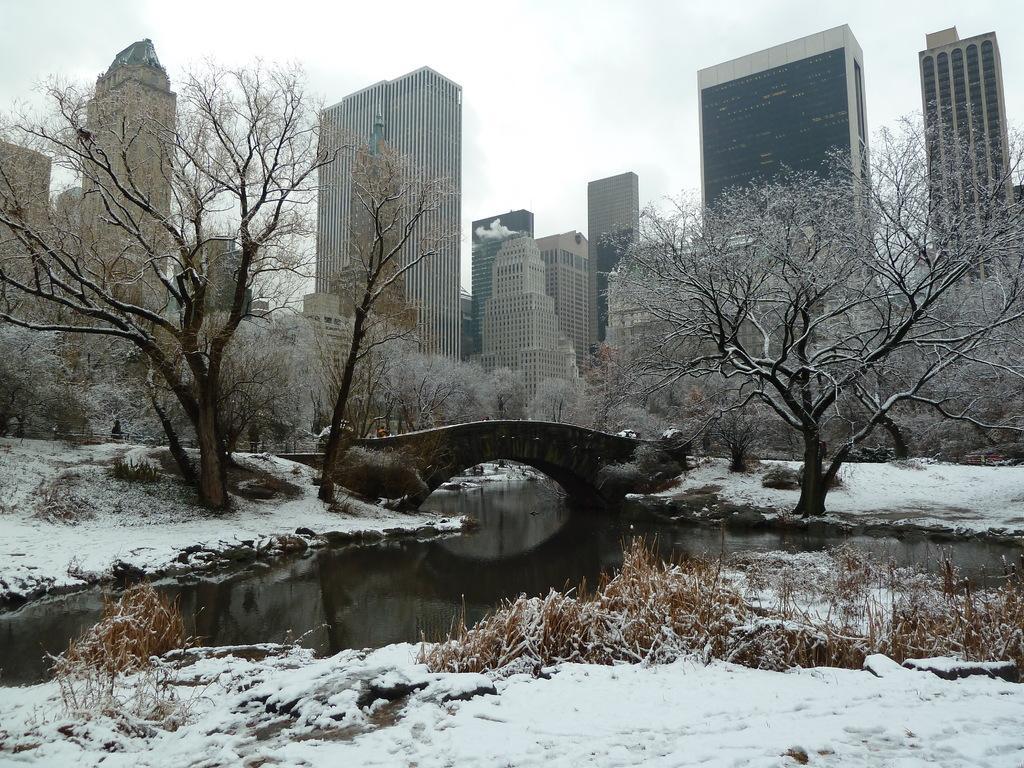How would you summarize this image in a sentence or two? At the downside this is the snow, this is water. In the middle there is a bridge, trees. These are the very big buildings in this image. 